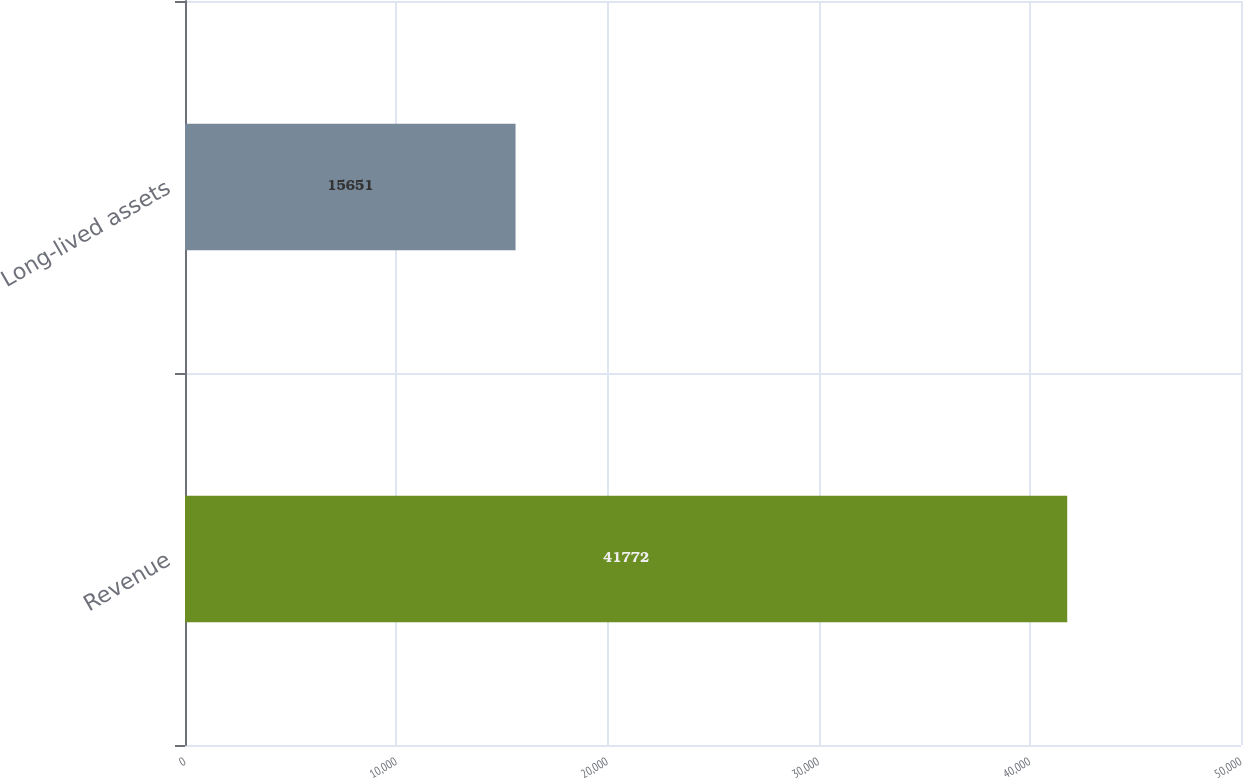<chart> <loc_0><loc_0><loc_500><loc_500><bar_chart><fcel>Revenue<fcel>Long-lived assets<nl><fcel>41772<fcel>15651<nl></chart> 